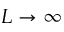<formula> <loc_0><loc_0><loc_500><loc_500>L \rightarrow \infty</formula> 